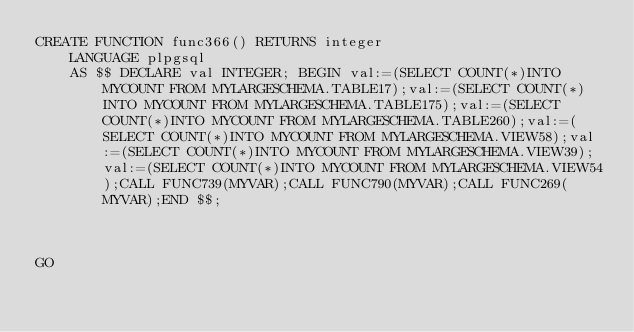Convert code to text. <code><loc_0><loc_0><loc_500><loc_500><_SQL_>CREATE FUNCTION func366() RETURNS integer
    LANGUAGE plpgsql
    AS $$ DECLARE val INTEGER; BEGIN val:=(SELECT COUNT(*)INTO MYCOUNT FROM MYLARGESCHEMA.TABLE17);val:=(SELECT COUNT(*)INTO MYCOUNT FROM MYLARGESCHEMA.TABLE175);val:=(SELECT COUNT(*)INTO MYCOUNT FROM MYLARGESCHEMA.TABLE260);val:=(SELECT COUNT(*)INTO MYCOUNT FROM MYLARGESCHEMA.VIEW58);val:=(SELECT COUNT(*)INTO MYCOUNT FROM MYLARGESCHEMA.VIEW39);val:=(SELECT COUNT(*)INTO MYCOUNT FROM MYLARGESCHEMA.VIEW54);CALL FUNC739(MYVAR);CALL FUNC790(MYVAR);CALL FUNC269(MYVAR);END $$;



GO</code> 